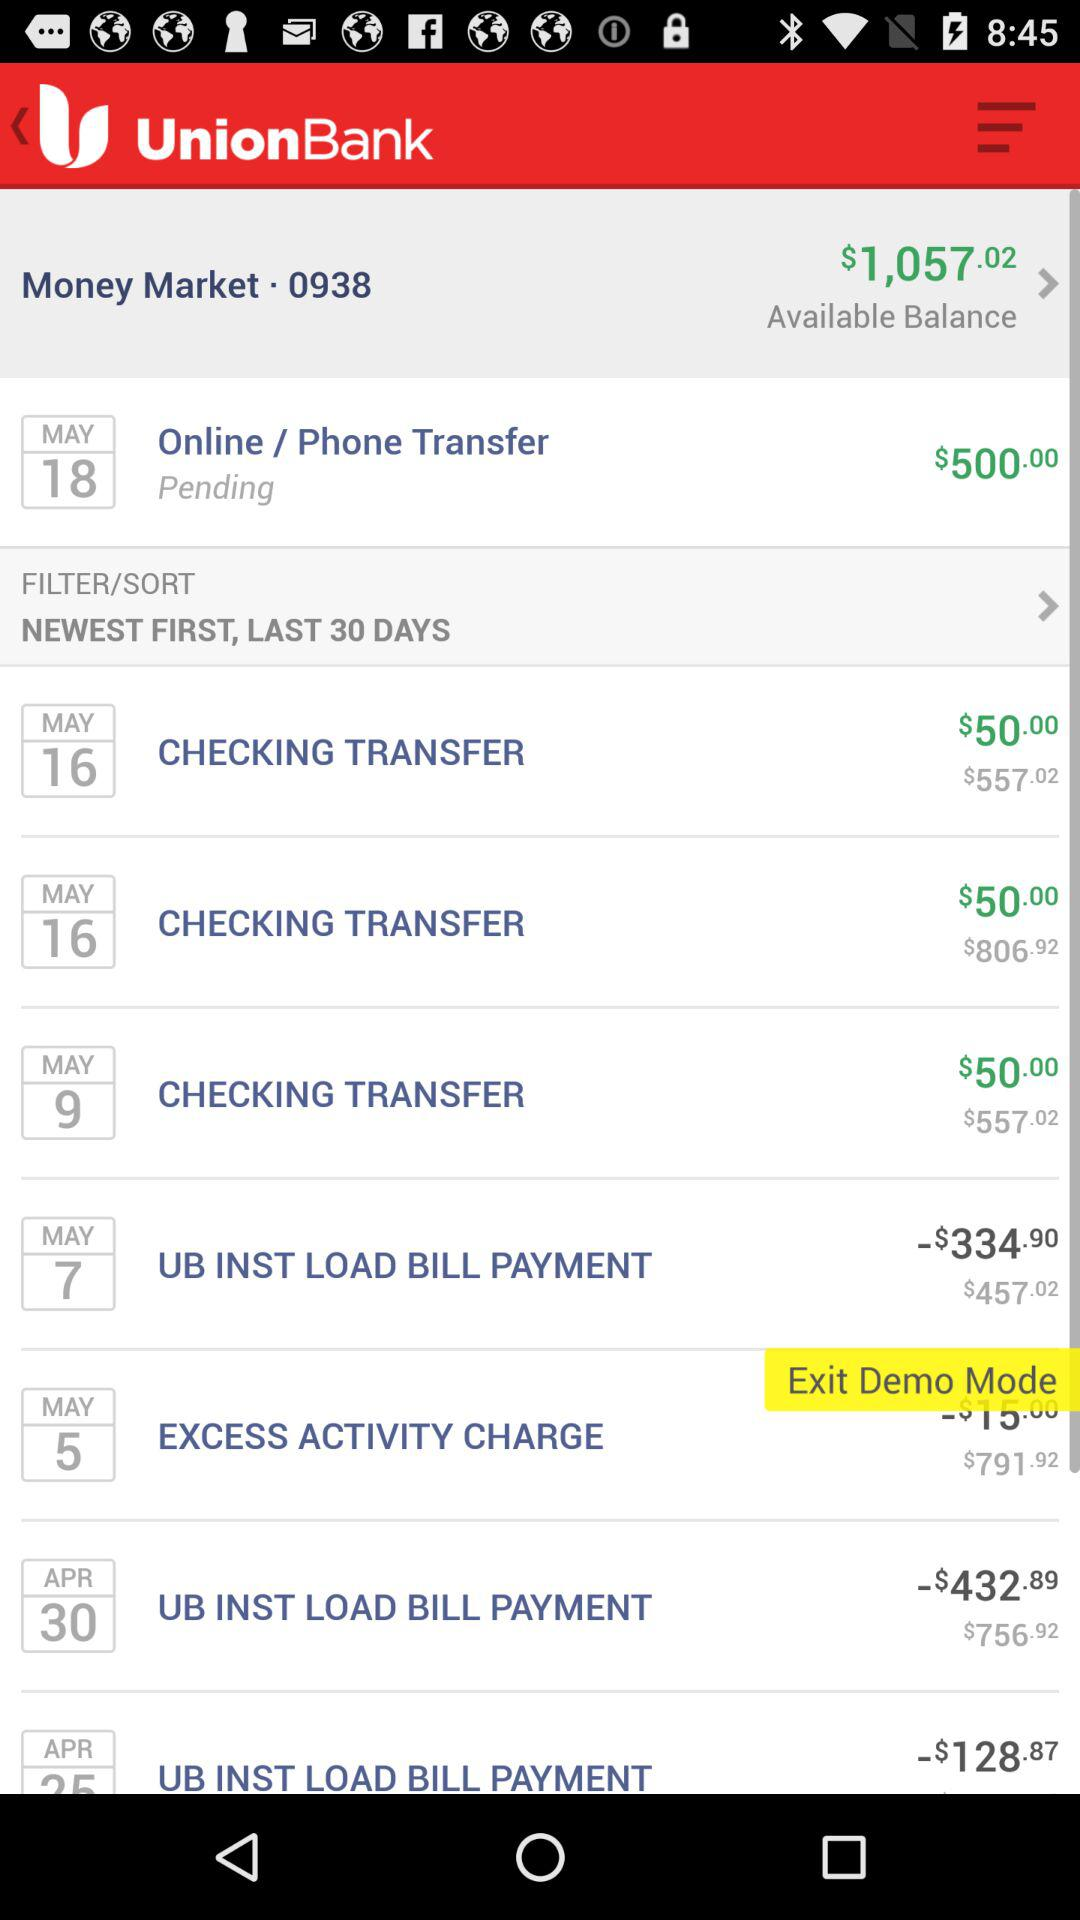What is the status of the online/phone transfer on May 18? The status is "Pending". 